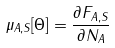<formula> <loc_0><loc_0><loc_500><loc_500>\mu _ { A , S } [ \Theta ] = \frac { \partial F _ { A , S } } { \partial N _ { A } }</formula> 